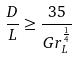<formula> <loc_0><loc_0><loc_500><loc_500>\frac { D } { L } \geq \frac { 3 5 } { G r _ { L } ^ { \frac { 1 } { 4 } } }</formula> 